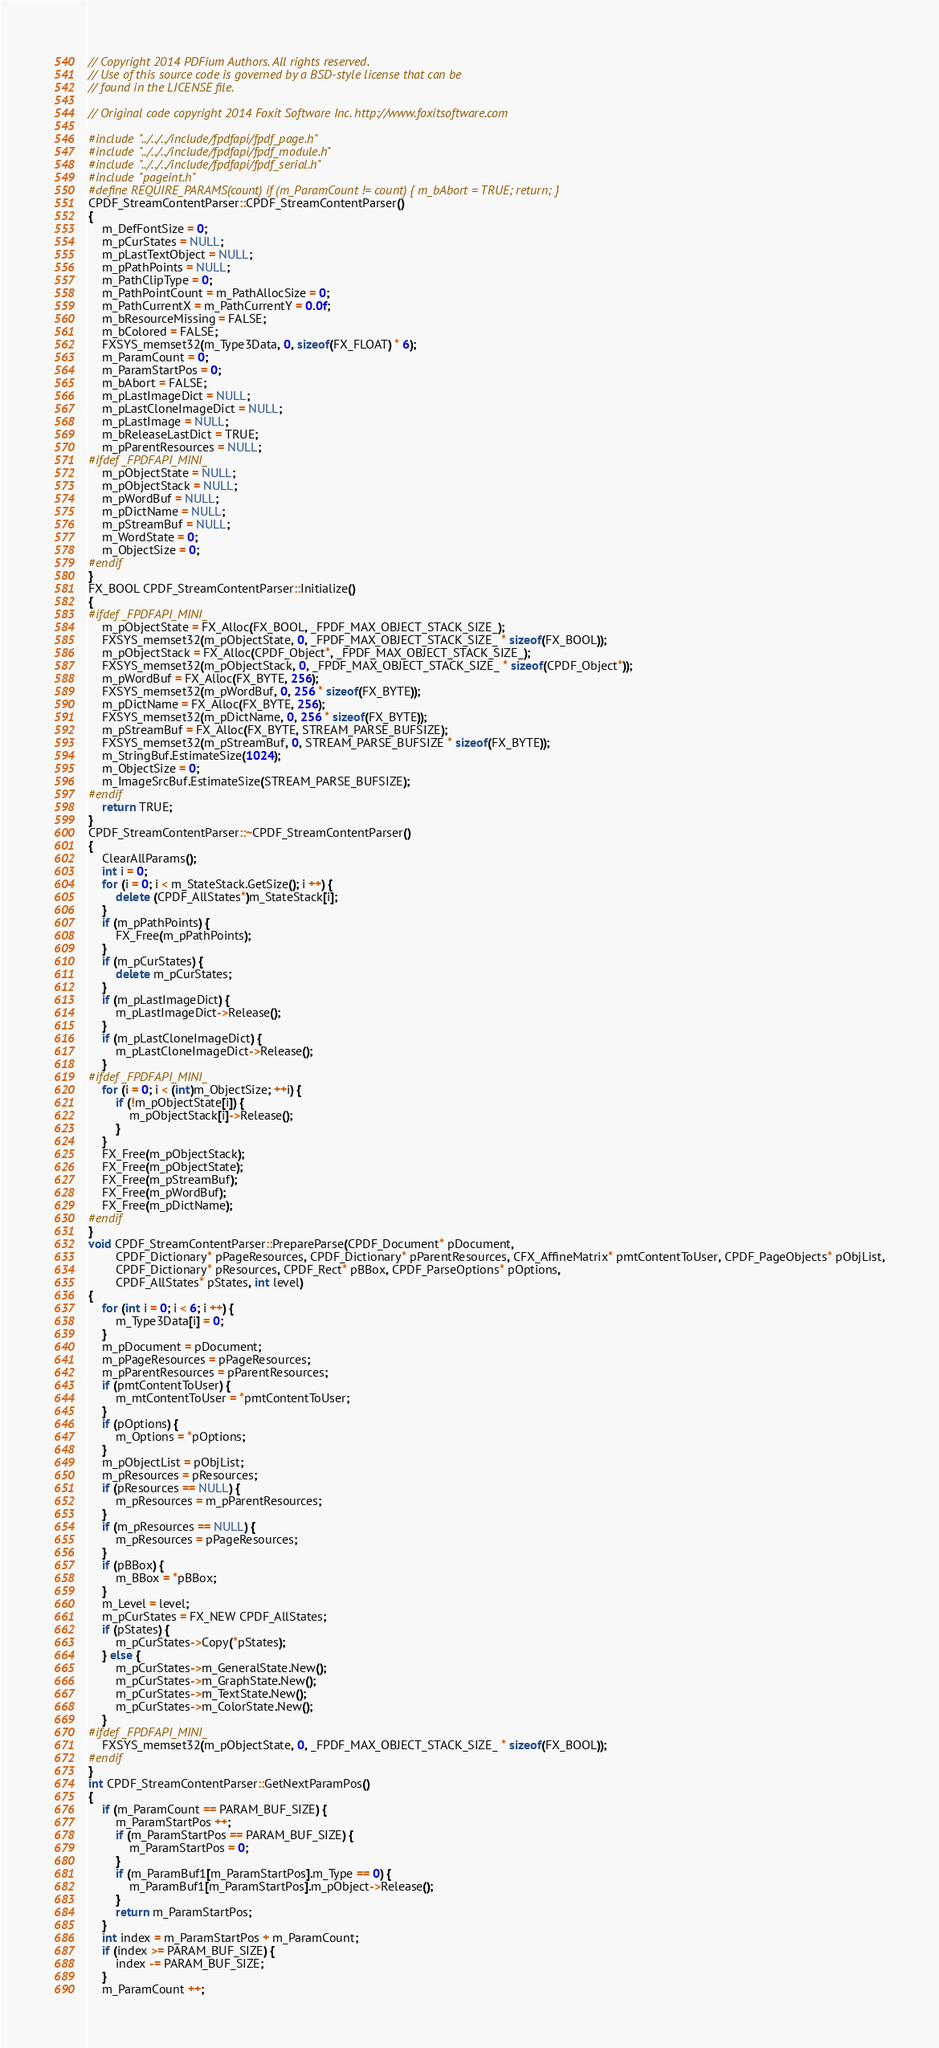<code> <loc_0><loc_0><loc_500><loc_500><_C++_>// Copyright 2014 PDFium Authors. All rights reserved.
// Use of this source code is governed by a BSD-style license that can be
// found in the LICENSE file.
 
// Original code copyright 2014 Foxit Software Inc. http://www.foxitsoftware.com

#include "../../../include/fpdfapi/fpdf_page.h"
#include "../../../include/fpdfapi/fpdf_module.h"
#include "../../../include/fpdfapi/fpdf_serial.h"
#include "pageint.h"
#define REQUIRE_PARAMS(count) if (m_ParamCount != count) { m_bAbort = TRUE; return; }
CPDF_StreamContentParser::CPDF_StreamContentParser()
{
    m_DefFontSize = 0;
    m_pCurStates = NULL;
    m_pLastTextObject = NULL;
    m_pPathPoints = NULL;
    m_PathClipType = 0;
    m_PathPointCount = m_PathAllocSize = 0;
    m_PathCurrentX = m_PathCurrentY = 0.0f;
    m_bResourceMissing = FALSE;
    m_bColored = FALSE;
    FXSYS_memset32(m_Type3Data, 0, sizeof(FX_FLOAT) * 6);
    m_ParamCount = 0;
    m_ParamStartPos = 0;
    m_bAbort = FALSE;
    m_pLastImageDict = NULL;
    m_pLastCloneImageDict = NULL;
    m_pLastImage = NULL;
    m_bReleaseLastDict = TRUE;
    m_pParentResources = NULL;
#ifdef _FPDFAPI_MINI_
    m_pObjectState = NULL;
    m_pObjectStack = NULL;
    m_pWordBuf = NULL;
    m_pDictName = NULL;
    m_pStreamBuf = NULL;
    m_WordState = 0;
    m_ObjectSize = 0;
#endif
}
FX_BOOL CPDF_StreamContentParser::Initialize()
{
#ifdef _FPDFAPI_MINI_
    m_pObjectState = FX_Alloc(FX_BOOL, _FPDF_MAX_OBJECT_STACK_SIZE_);
    FXSYS_memset32(m_pObjectState, 0, _FPDF_MAX_OBJECT_STACK_SIZE_ * sizeof(FX_BOOL));
    m_pObjectStack = FX_Alloc(CPDF_Object*, _FPDF_MAX_OBJECT_STACK_SIZE_);
    FXSYS_memset32(m_pObjectStack, 0, _FPDF_MAX_OBJECT_STACK_SIZE_ * sizeof(CPDF_Object*));
    m_pWordBuf = FX_Alloc(FX_BYTE, 256);
    FXSYS_memset32(m_pWordBuf, 0, 256 * sizeof(FX_BYTE));
    m_pDictName = FX_Alloc(FX_BYTE, 256);
    FXSYS_memset32(m_pDictName, 0, 256 * sizeof(FX_BYTE));
    m_pStreamBuf = FX_Alloc(FX_BYTE, STREAM_PARSE_BUFSIZE);
    FXSYS_memset32(m_pStreamBuf, 0, STREAM_PARSE_BUFSIZE * sizeof(FX_BYTE));
    m_StringBuf.EstimateSize(1024);
    m_ObjectSize = 0;
    m_ImageSrcBuf.EstimateSize(STREAM_PARSE_BUFSIZE);
#endif
    return TRUE;
}
CPDF_StreamContentParser::~CPDF_StreamContentParser()
{
    ClearAllParams();
    int i = 0;
    for (i = 0; i < m_StateStack.GetSize(); i ++) {
        delete (CPDF_AllStates*)m_StateStack[i];
    }
    if (m_pPathPoints) {
        FX_Free(m_pPathPoints);
    }
    if (m_pCurStates) {
        delete m_pCurStates;
    }
    if (m_pLastImageDict) {
        m_pLastImageDict->Release();
    }
    if (m_pLastCloneImageDict) {
        m_pLastCloneImageDict->Release();
    }
#ifdef _FPDFAPI_MINI_
    for (i = 0; i < (int)m_ObjectSize; ++i) {
        if (!m_pObjectState[i]) {
            m_pObjectStack[i]->Release();
        }
    }
    FX_Free(m_pObjectStack);
    FX_Free(m_pObjectState);
    FX_Free(m_pStreamBuf);
    FX_Free(m_pWordBuf);
    FX_Free(m_pDictName);
#endif
}
void CPDF_StreamContentParser::PrepareParse(CPDF_Document* pDocument,
        CPDF_Dictionary* pPageResources, CPDF_Dictionary* pParentResources, CFX_AffineMatrix* pmtContentToUser, CPDF_PageObjects* pObjList,
        CPDF_Dictionary* pResources, CPDF_Rect* pBBox, CPDF_ParseOptions* pOptions,
        CPDF_AllStates* pStates, int level)
{
    for (int i = 0; i < 6; i ++) {
        m_Type3Data[i] = 0;
    }
    m_pDocument = pDocument;
    m_pPageResources = pPageResources;
    m_pParentResources = pParentResources;
    if (pmtContentToUser) {
        m_mtContentToUser = *pmtContentToUser;
    }
    if (pOptions) {
        m_Options = *pOptions;
    }
    m_pObjectList = pObjList;
    m_pResources = pResources;
    if (pResources == NULL) {
        m_pResources = m_pParentResources;
    }
    if (m_pResources == NULL) {
        m_pResources = pPageResources;
    }
    if (pBBox) {
        m_BBox = *pBBox;
    }
    m_Level = level;
    m_pCurStates = FX_NEW CPDF_AllStates;
    if (pStates) {
        m_pCurStates->Copy(*pStates);
    } else {
        m_pCurStates->m_GeneralState.New();
        m_pCurStates->m_GraphState.New();
        m_pCurStates->m_TextState.New();
        m_pCurStates->m_ColorState.New();
    }
#ifdef _FPDFAPI_MINI_
    FXSYS_memset32(m_pObjectState, 0, _FPDF_MAX_OBJECT_STACK_SIZE_ * sizeof(FX_BOOL));
#endif
}
int CPDF_StreamContentParser::GetNextParamPos()
{
    if (m_ParamCount == PARAM_BUF_SIZE) {
        m_ParamStartPos ++;
        if (m_ParamStartPos == PARAM_BUF_SIZE) {
            m_ParamStartPos = 0;
        }
        if (m_ParamBuf1[m_ParamStartPos].m_Type == 0) {
            m_ParamBuf1[m_ParamStartPos].m_pObject->Release();
        }
        return m_ParamStartPos;
    }
    int index = m_ParamStartPos + m_ParamCount;
    if (index >= PARAM_BUF_SIZE) {
        index -= PARAM_BUF_SIZE;
    }
    m_ParamCount ++;</code> 